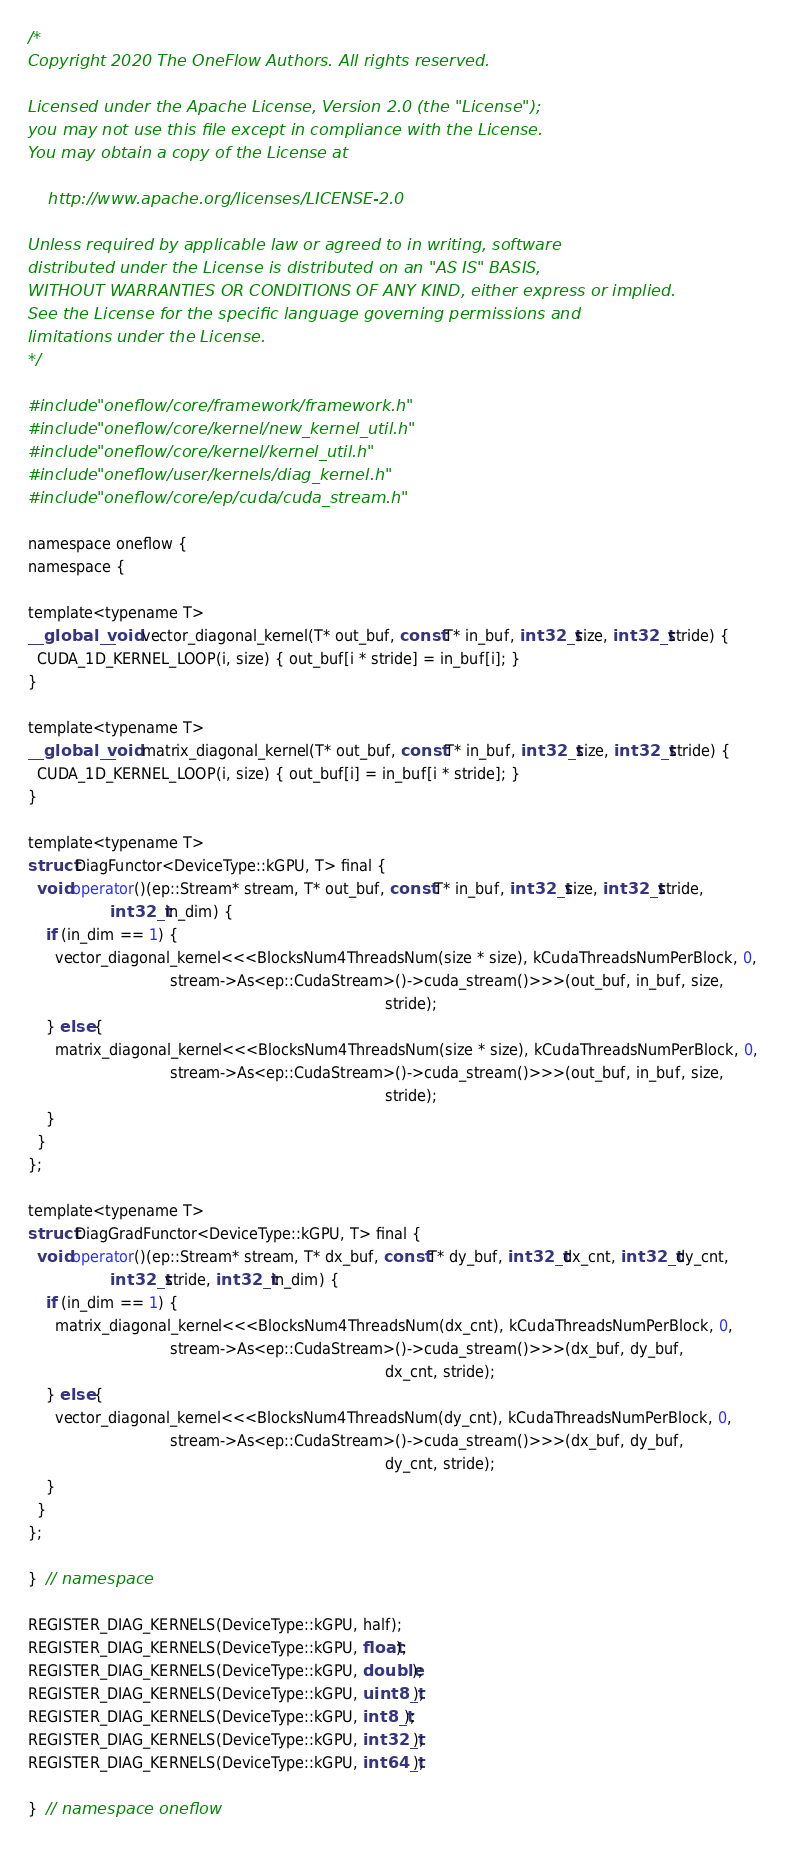<code> <loc_0><loc_0><loc_500><loc_500><_Cuda_>/*
Copyright 2020 The OneFlow Authors. All rights reserved.

Licensed under the Apache License, Version 2.0 (the "License");
you may not use this file except in compliance with the License.
You may obtain a copy of the License at

    http://www.apache.org/licenses/LICENSE-2.0

Unless required by applicable law or agreed to in writing, software
distributed under the License is distributed on an "AS IS" BASIS,
WITHOUT WARRANTIES OR CONDITIONS OF ANY KIND, either express or implied.
See the License for the specific language governing permissions and
limitations under the License.
*/

#include "oneflow/core/framework/framework.h"
#include "oneflow/core/kernel/new_kernel_util.h"
#include "oneflow/core/kernel/kernel_util.h"
#include "oneflow/user/kernels/diag_kernel.h"
#include "oneflow/core/ep/cuda/cuda_stream.h"

namespace oneflow {
namespace {

template<typename T>
__global__ void vector_diagonal_kernel(T* out_buf, const T* in_buf, int32_t size, int32_t stride) {
  CUDA_1D_KERNEL_LOOP(i, size) { out_buf[i * stride] = in_buf[i]; }
}

template<typename T>
__global__ void matrix_diagonal_kernel(T* out_buf, const T* in_buf, int32_t size, int32_t stride) {
  CUDA_1D_KERNEL_LOOP(i, size) { out_buf[i] = in_buf[i * stride]; }
}

template<typename T>
struct DiagFunctor<DeviceType::kGPU, T> final {
  void operator()(ep::Stream* stream, T* out_buf, const T* in_buf, int32_t size, int32_t stride,
                  int32_t in_dim) {
    if (in_dim == 1) {
      vector_diagonal_kernel<<<BlocksNum4ThreadsNum(size * size), kCudaThreadsNumPerBlock, 0,
                               stream->As<ep::CudaStream>()->cuda_stream()>>>(out_buf, in_buf, size,
                                                                              stride);
    } else {
      matrix_diagonal_kernel<<<BlocksNum4ThreadsNum(size * size), kCudaThreadsNumPerBlock, 0,
                               stream->As<ep::CudaStream>()->cuda_stream()>>>(out_buf, in_buf, size,
                                                                              stride);
    }
  }
};

template<typename T>
struct DiagGradFunctor<DeviceType::kGPU, T> final {
  void operator()(ep::Stream* stream, T* dx_buf, const T* dy_buf, int32_t dx_cnt, int32_t dy_cnt,
                  int32_t stride, int32_t in_dim) {
    if (in_dim == 1) {
      matrix_diagonal_kernel<<<BlocksNum4ThreadsNum(dx_cnt), kCudaThreadsNumPerBlock, 0,
                               stream->As<ep::CudaStream>()->cuda_stream()>>>(dx_buf, dy_buf,
                                                                              dx_cnt, stride);
    } else {
      vector_diagonal_kernel<<<BlocksNum4ThreadsNum(dy_cnt), kCudaThreadsNumPerBlock, 0,
                               stream->As<ep::CudaStream>()->cuda_stream()>>>(dx_buf, dy_buf,
                                                                              dy_cnt, stride);
    }
  }
};

}  // namespace

REGISTER_DIAG_KERNELS(DeviceType::kGPU, half);
REGISTER_DIAG_KERNELS(DeviceType::kGPU, float);
REGISTER_DIAG_KERNELS(DeviceType::kGPU, double);
REGISTER_DIAG_KERNELS(DeviceType::kGPU, uint8_t);
REGISTER_DIAG_KERNELS(DeviceType::kGPU, int8_t);
REGISTER_DIAG_KERNELS(DeviceType::kGPU, int32_t);
REGISTER_DIAG_KERNELS(DeviceType::kGPU, int64_t);

}  // namespace oneflow
</code> 